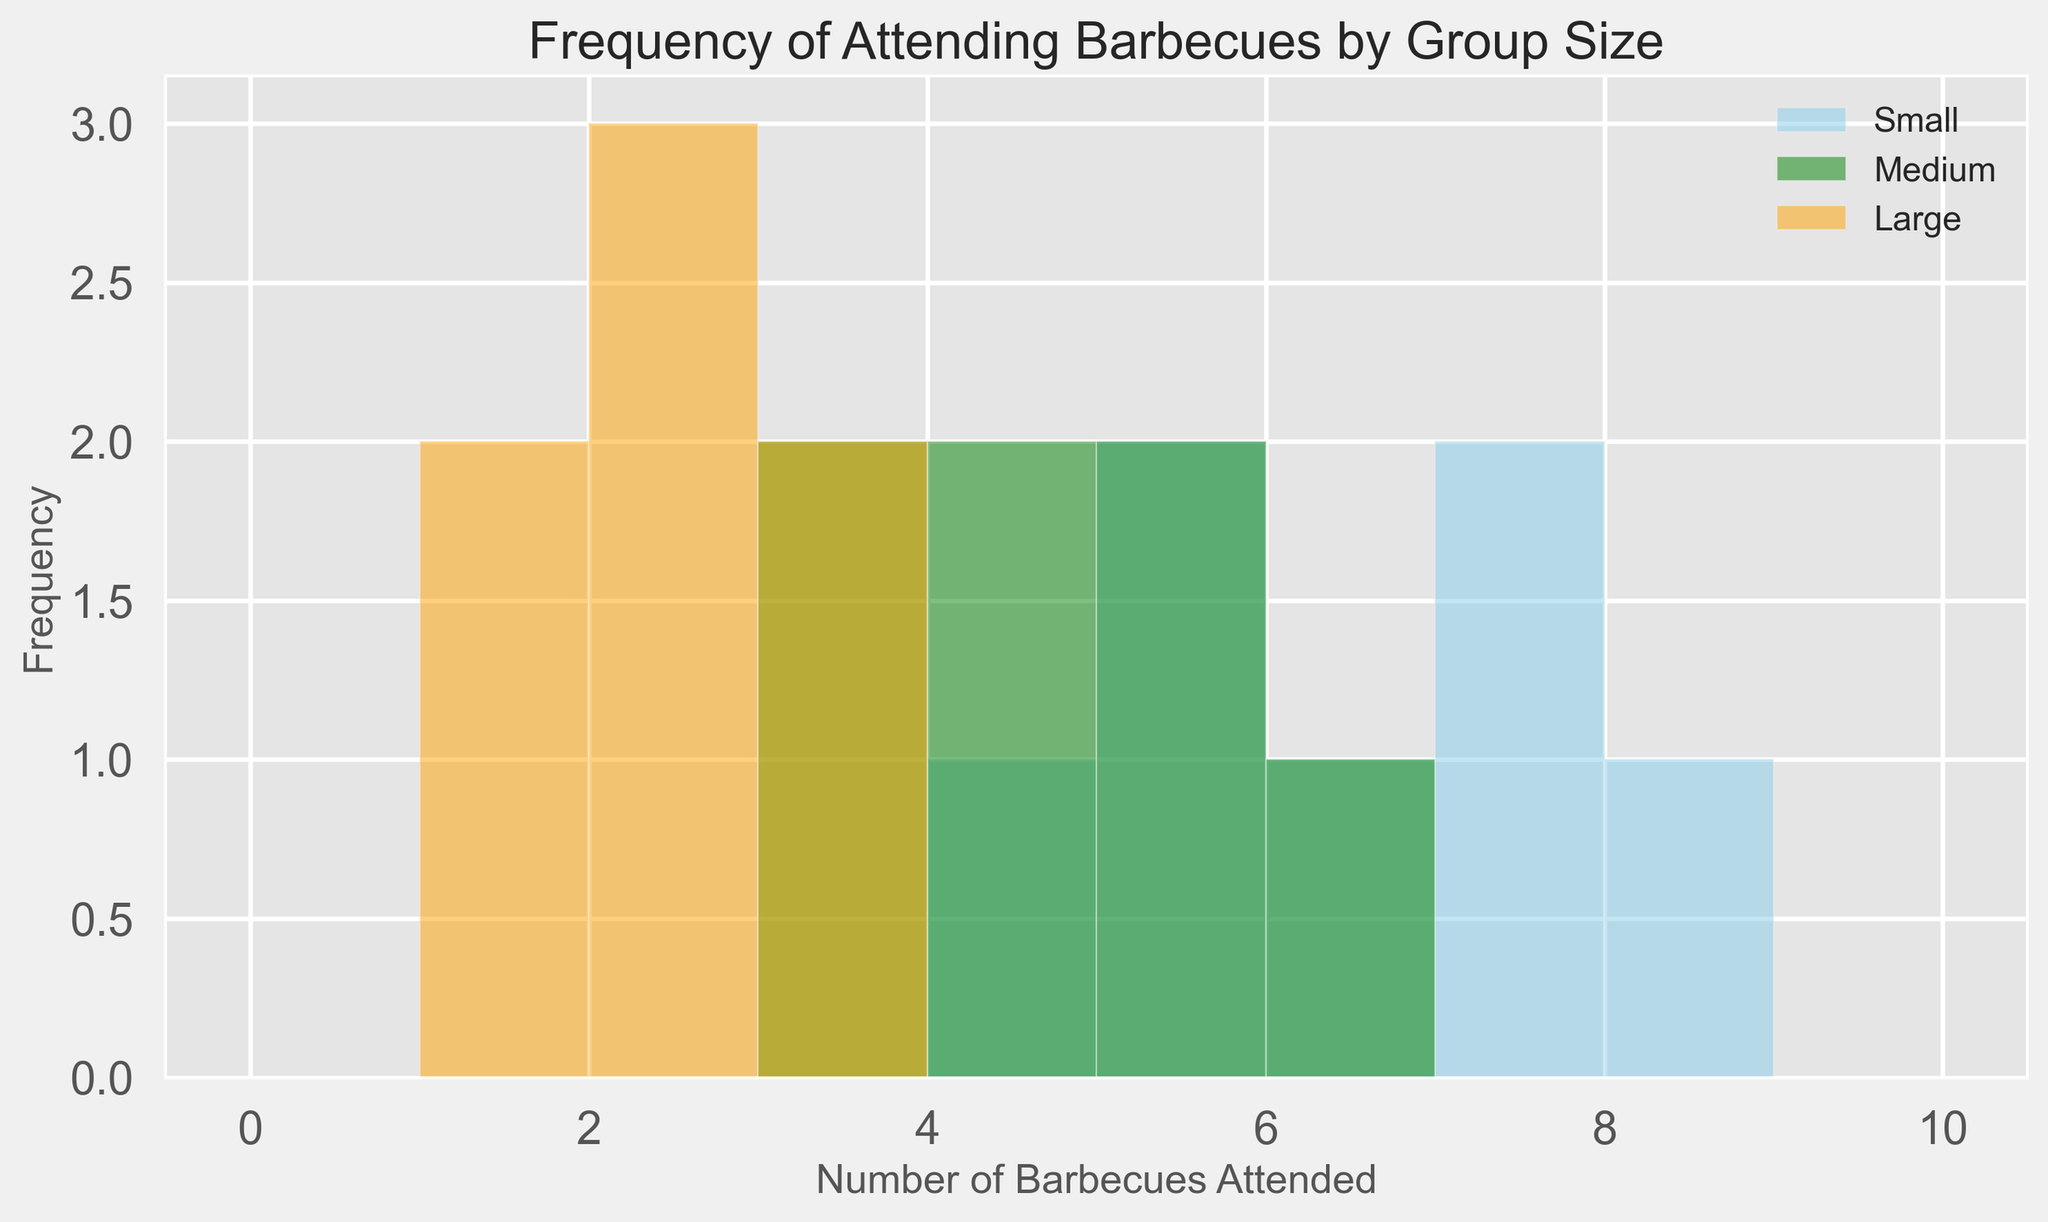What is the most common frequency of attending barbecues in the small group? By looking at the height of the bars colored in skyblue representing the small group, the tallest bar corresponds to a frequency of 5 and 7. This means 5 and 7 are the most common.
Answer: 5 and 7 Which group size attends the least number of barbecues most frequently? The orange bars represent the large group. The tallest orange bar corresponds to a frequency of 2, showing that large groups mostly attend 2 barbecues.
Answer: large What is the difference between the most common frequencies of attending barbecues in the small and medium groups? The most common frequency in the small group is 5 and 7, while in the medium group (green bars), the most common frequency is 3 and 4. The difference between 5 and 3 is 2, and the difference between 7 and 4 is 3.
Answer: 2 and 3 Which group size has the most spread out data for attending barbecues? Spread out data can be seen if there are bars reaching higher frequency values. The small group has bars reaching up to 8 barbecues, medium up to 6, and large up to 3.
Answer: small How many frequencies are there where the small group's frequency count is higher than the large group? By comparing each corresponding bar, the small group (sky blue) is higher in frequencies 4, 5, 6, 7, and 8 compared to the large group (orange), which is higher at 1 and 2 barbecues.
Answer: 5 What is the ratio of the most frequent attendance (highest bar height) for the small group versus the large group? The highest bar for the small group is 5 or 7, and the highest bar for the large group is 2. The ratio is 5/2 or 7/2.
Answer: 2.5 or 3.5 What can we infer about people attending barbecues based on group size from this histogram? From the histogram, small group attendees have more variability in the number of barbecues attended (ranging up to 8), whereas large group attendees predominantly attend fewer barbecues (no more than 3). Medium groups fall in between with a moderate spread.
Answer: small groups attend more and large groups attend fewer Which frequency is attended by all group sizes? Looking at the bars of all colors, frequency 5 is attended by small, medium, and large groups (skyblue, green, and orange bars are all present).
Answer: 5 